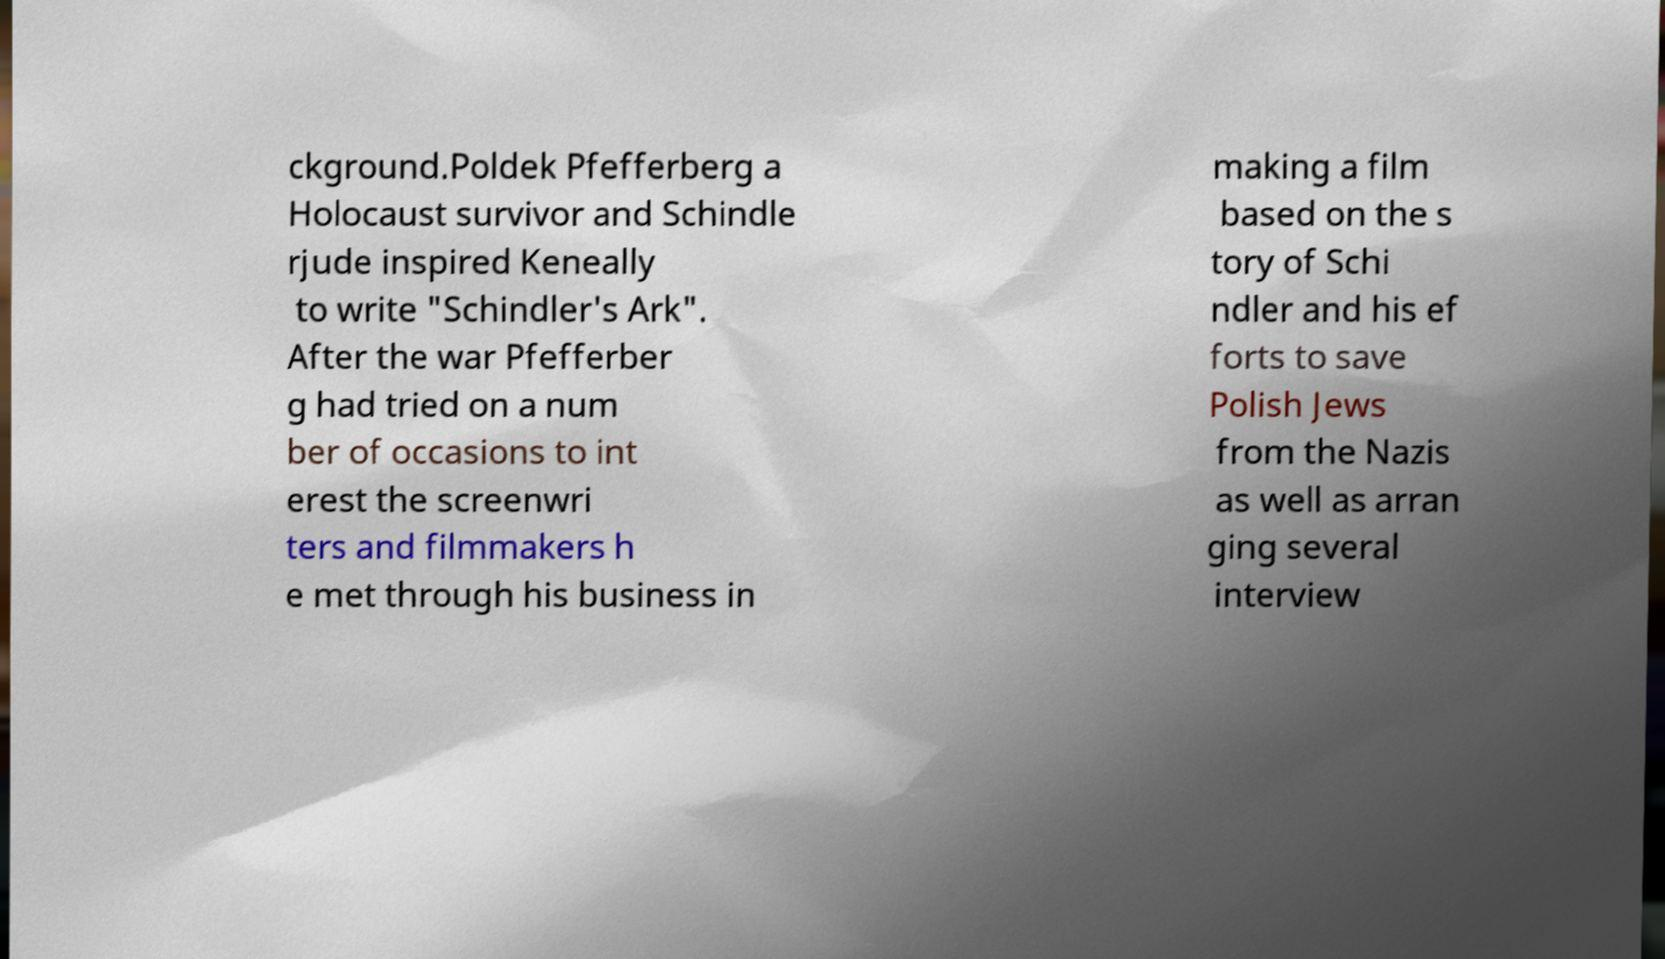For documentation purposes, I need the text within this image transcribed. Could you provide that? ckground.Poldek Pfefferberg a Holocaust survivor and Schindle rjude inspired Keneally to write "Schindler's Ark". After the war Pfefferber g had tried on a num ber of occasions to int erest the screenwri ters and filmmakers h e met through his business in making a film based on the s tory of Schi ndler and his ef forts to save Polish Jews from the Nazis as well as arran ging several interview 